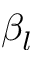Convert formula to latex. <formula><loc_0><loc_0><loc_500><loc_500>\beta _ { l }</formula> 